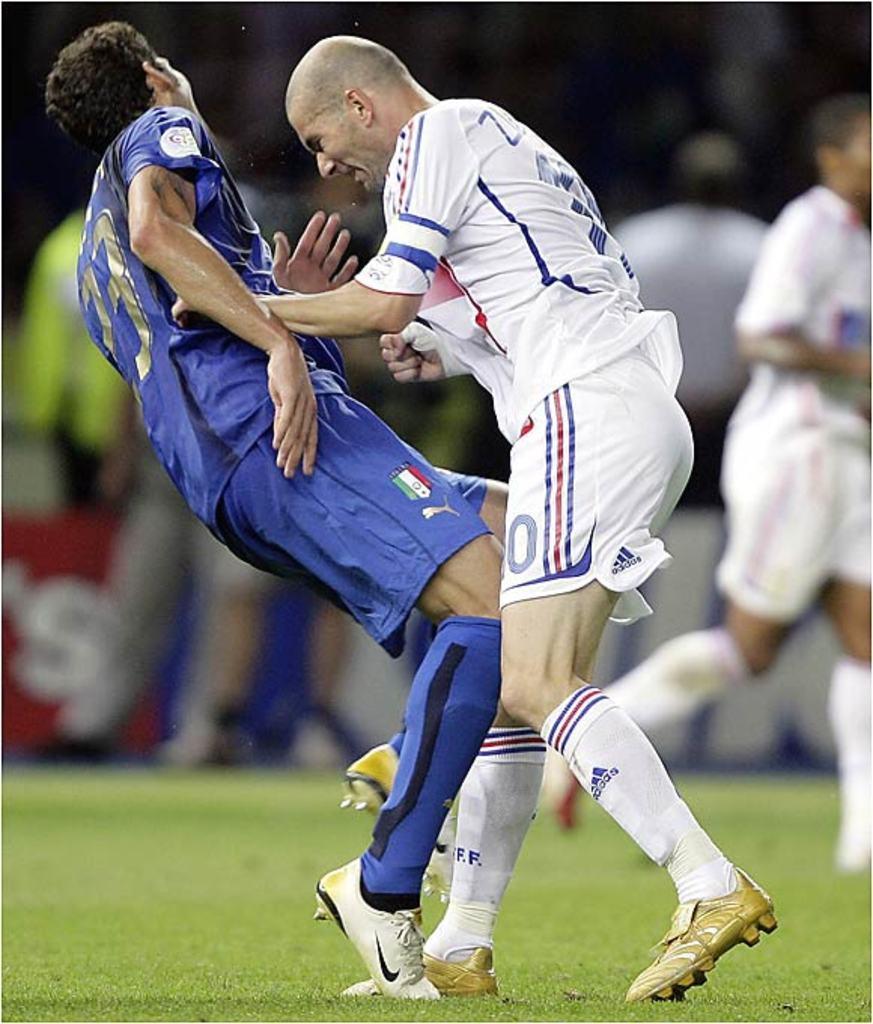How would you summarize this image in a sentence or two? In this image in the front there are persons playing. In the background there are persons standing and there is a board with some text written on it. In the center there is grass on the ground and there is a person running. 